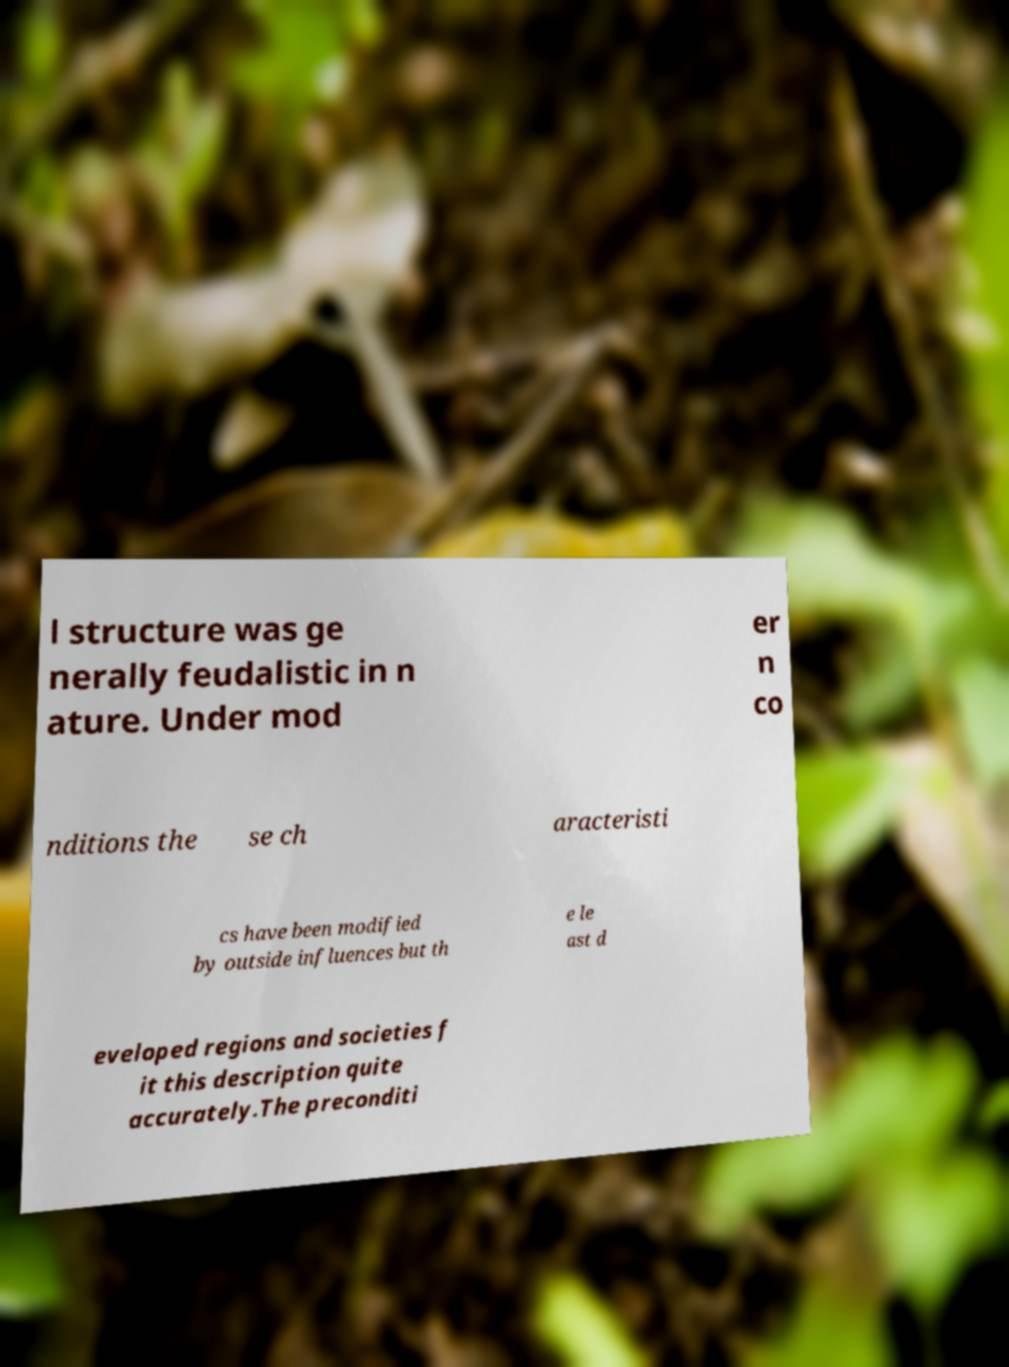Can you accurately transcribe the text from the provided image for me? l structure was ge nerally feudalistic in n ature. Under mod er n co nditions the se ch aracteristi cs have been modified by outside influences but th e le ast d eveloped regions and societies f it this description quite accurately.The preconditi 